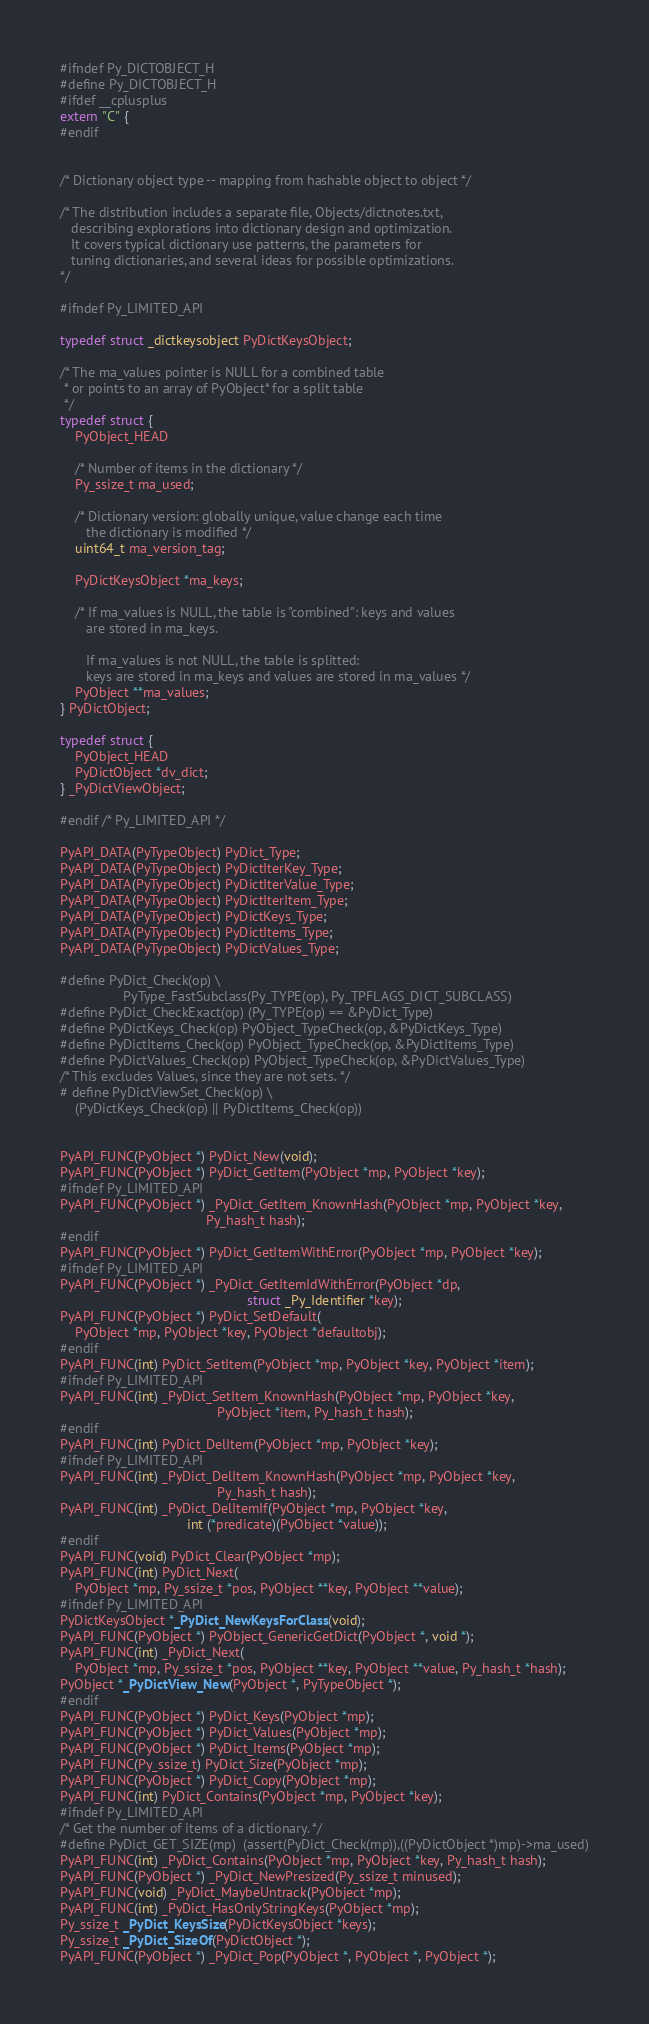Convert code to text. <code><loc_0><loc_0><loc_500><loc_500><_C_>#ifndef Py_DICTOBJECT_H
#define Py_DICTOBJECT_H
#ifdef __cplusplus
extern "C" {
#endif


/* Dictionary object type -- mapping from hashable object to object */

/* The distribution includes a separate file, Objects/dictnotes.txt,
   describing explorations into dictionary design and optimization.
   It covers typical dictionary use patterns, the parameters for
   tuning dictionaries, and several ideas for possible optimizations.
*/

#ifndef Py_LIMITED_API

typedef struct _dictkeysobject PyDictKeysObject;

/* The ma_values pointer is NULL for a combined table
 * or points to an array of PyObject* for a split table
 */
typedef struct {
    PyObject_HEAD

    /* Number of items in the dictionary */
    Py_ssize_t ma_used;

    /* Dictionary version: globally unique, value change each time
       the dictionary is modified */
    uint64_t ma_version_tag;

    PyDictKeysObject *ma_keys;

    /* If ma_values is NULL, the table is "combined": keys and values
       are stored in ma_keys.

       If ma_values is not NULL, the table is splitted:
       keys are stored in ma_keys and values are stored in ma_values */
    PyObject **ma_values;
} PyDictObject;

typedef struct {
    PyObject_HEAD
    PyDictObject *dv_dict;
} _PyDictViewObject;

#endif /* Py_LIMITED_API */

PyAPI_DATA(PyTypeObject) PyDict_Type;
PyAPI_DATA(PyTypeObject) PyDictIterKey_Type;
PyAPI_DATA(PyTypeObject) PyDictIterValue_Type;
PyAPI_DATA(PyTypeObject) PyDictIterItem_Type;
PyAPI_DATA(PyTypeObject) PyDictKeys_Type;
PyAPI_DATA(PyTypeObject) PyDictItems_Type;
PyAPI_DATA(PyTypeObject) PyDictValues_Type;

#define PyDict_Check(op) \
                 PyType_FastSubclass(Py_TYPE(op), Py_TPFLAGS_DICT_SUBCLASS)
#define PyDict_CheckExact(op) (Py_TYPE(op) == &PyDict_Type)
#define PyDictKeys_Check(op) PyObject_TypeCheck(op, &PyDictKeys_Type)
#define PyDictItems_Check(op) PyObject_TypeCheck(op, &PyDictItems_Type)
#define PyDictValues_Check(op) PyObject_TypeCheck(op, &PyDictValues_Type)
/* This excludes Values, since they are not sets. */
# define PyDictViewSet_Check(op) \
    (PyDictKeys_Check(op) || PyDictItems_Check(op))


PyAPI_FUNC(PyObject *) PyDict_New(void);
PyAPI_FUNC(PyObject *) PyDict_GetItem(PyObject *mp, PyObject *key);
#ifndef Py_LIMITED_API
PyAPI_FUNC(PyObject *) _PyDict_GetItem_KnownHash(PyObject *mp, PyObject *key,
                                       Py_hash_t hash);
#endif
PyAPI_FUNC(PyObject *) PyDict_GetItemWithError(PyObject *mp, PyObject *key);
#ifndef Py_LIMITED_API
PyAPI_FUNC(PyObject *) _PyDict_GetItemIdWithError(PyObject *dp,
                                                  struct _Py_Identifier *key);
PyAPI_FUNC(PyObject *) PyDict_SetDefault(
    PyObject *mp, PyObject *key, PyObject *defaultobj);
#endif
PyAPI_FUNC(int) PyDict_SetItem(PyObject *mp, PyObject *key, PyObject *item);
#ifndef Py_LIMITED_API
PyAPI_FUNC(int) _PyDict_SetItem_KnownHash(PyObject *mp, PyObject *key,
                                          PyObject *item, Py_hash_t hash);
#endif
PyAPI_FUNC(int) PyDict_DelItem(PyObject *mp, PyObject *key);
#ifndef Py_LIMITED_API
PyAPI_FUNC(int) _PyDict_DelItem_KnownHash(PyObject *mp, PyObject *key,
                                          Py_hash_t hash);
PyAPI_FUNC(int) _PyDict_DelItemIf(PyObject *mp, PyObject *key,
                                  int (*predicate)(PyObject *value));
#endif
PyAPI_FUNC(void) PyDict_Clear(PyObject *mp);
PyAPI_FUNC(int) PyDict_Next(
    PyObject *mp, Py_ssize_t *pos, PyObject **key, PyObject **value);
#ifndef Py_LIMITED_API
PyDictKeysObject *_PyDict_NewKeysForClass(void);
PyAPI_FUNC(PyObject *) PyObject_GenericGetDict(PyObject *, void *);
PyAPI_FUNC(int) _PyDict_Next(
    PyObject *mp, Py_ssize_t *pos, PyObject **key, PyObject **value, Py_hash_t *hash);
PyObject *_PyDictView_New(PyObject *, PyTypeObject *);
#endif
PyAPI_FUNC(PyObject *) PyDict_Keys(PyObject *mp);
PyAPI_FUNC(PyObject *) PyDict_Values(PyObject *mp);
PyAPI_FUNC(PyObject *) PyDict_Items(PyObject *mp);
PyAPI_FUNC(Py_ssize_t) PyDict_Size(PyObject *mp);
PyAPI_FUNC(PyObject *) PyDict_Copy(PyObject *mp);
PyAPI_FUNC(int) PyDict_Contains(PyObject *mp, PyObject *key);
#ifndef Py_LIMITED_API
/* Get the number of items of a dictionary. */
#define PyDict_GET_SIZE(mp)  (assert(PyDict_Check(mp)),((PyDictObject *)mp)->ma_used)
PyAPI_FUNC(int) _PyDict_Contains(PyObject *mp, PyObject *key, Py_hash_t hash);
PyAPI_FUNC(PyObject *) _PyDict_NewPresized(Py_ssize_t minused);
PyAPI_FUNC(void) _PyDict_MaybeUntrack(PyObject *mp);
PyAPI_FUNC(int) _PyDict_HasOnlyStringKeys(PyObject *mp);
Py_ssize_t _PyDict_KeysSize(PyDictKeysObject *keys);
Py_ssize_t _PyDict_SizeOf(PyDictObject *);
PyAPI_FUNC(PyObject *) _PyDict_Pop(PyObject *, PyObject *, PyObject *);</code> 